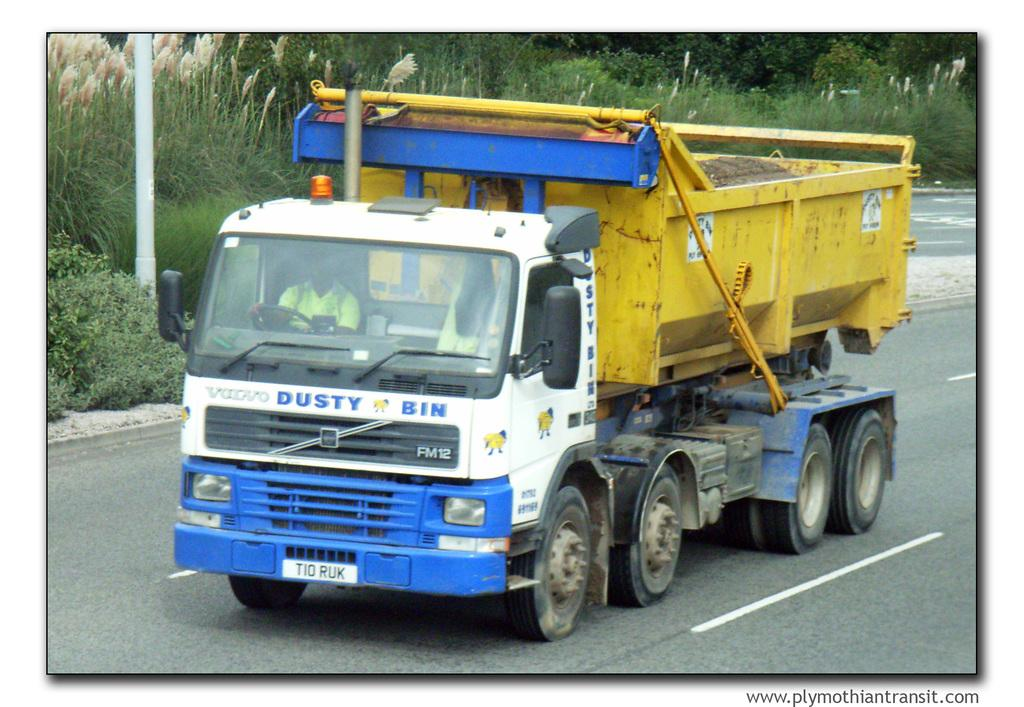What is the main subject of the image? There is a vehicle in the image. Who or what is inside the vehicle? There is a person sitting in the vehicle. What can be seen in the background of the image? There is a pole, plants, and trees in the background of the image. What type of wool is being used to make the scale in the image? There is no wool or scale present in the image. 